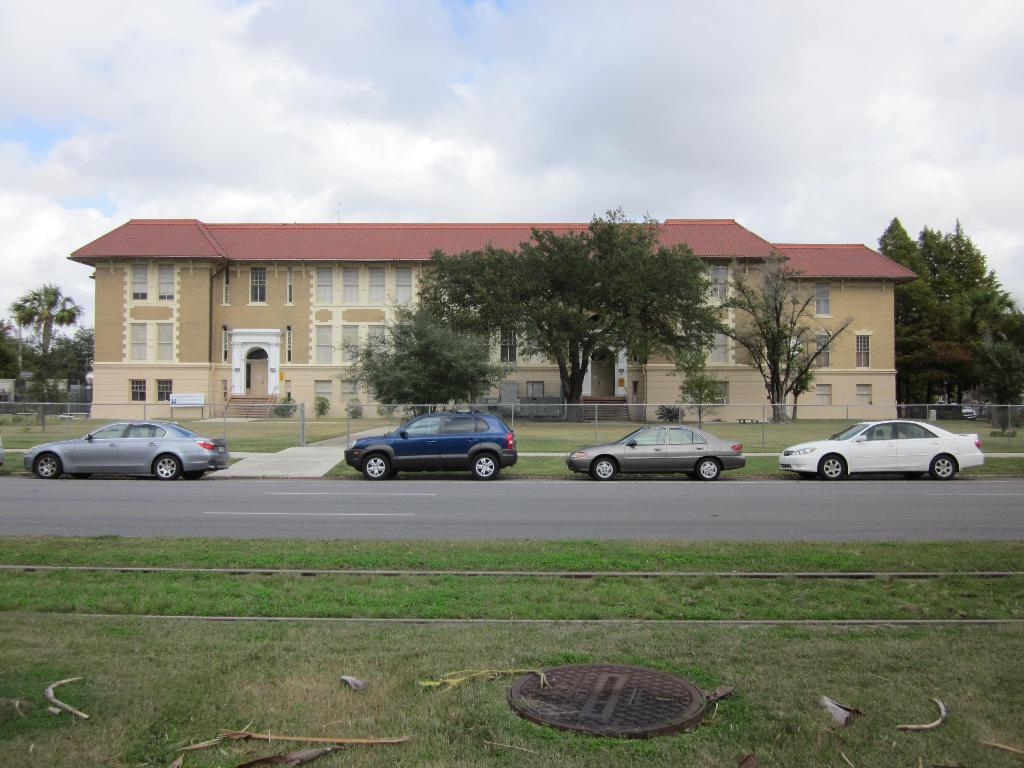What type of structure is present in the image? There is a house in the image. What features can be seen on the house? The house has windows and doors. What else can be seen on the property besides the house? There are vehicles on the road, fencing, trees, plants, and a manhole in the garden. What is visible in the background of the image? The sky is visible in the image. Reasoning: Let' Let's think step by step in order to produce the conversation. We start by identifying the main subject in the image, which is the house. Then, we expand the conversation to include other features and objects that are also visible, such as the windows, doors, vehicles, fencing, trees, plants, manhole, and sky. Each question is designed to elicit a specific detail about the image that is known from the provided facts. Absurd Question/Answer: What language is the manhole cover written in? There is no indication of any language on the manhole cover in the image. What type of flame can be seen coming from the trees in the image? There are no flames present in the image; it features a house, vehicles, fencing, trees, plants, and a manhole in the garden. 